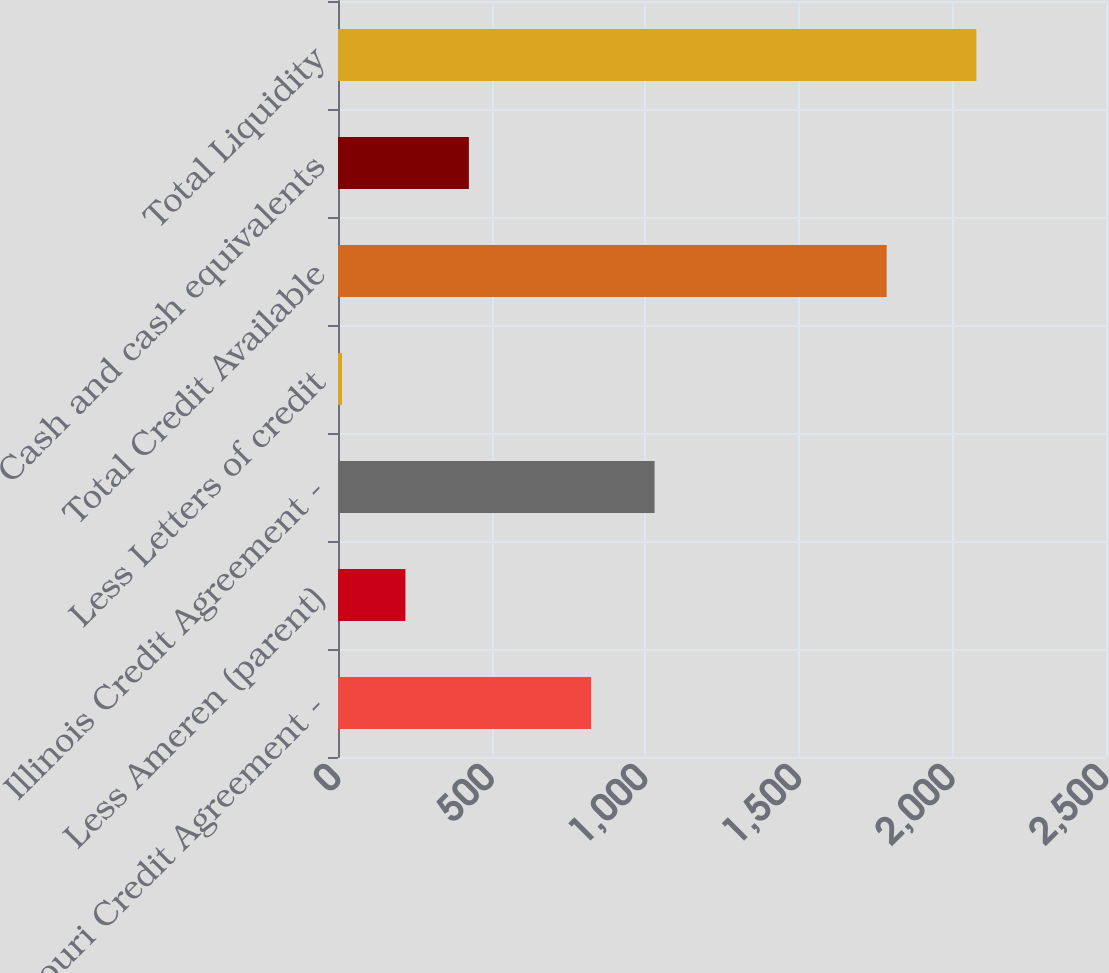<chart> <loc_0><loc_0><loc_500><loc_500><bar_chart><fcel>Missouri Credit Agreement -<fcel>Less Ameren (parent)<fcel>Illinois Credit Agreement -<fcel>Less Letters of credit<fcel>Total Credit Available<fcel>Cash and cash equivalents<fcel>Total Liquidity<nl><fcel>824<fcel>219.5<fcel>1030.5<fcel>13<fcel>1786<fcel>426<fcel>2078<nl></chart> 